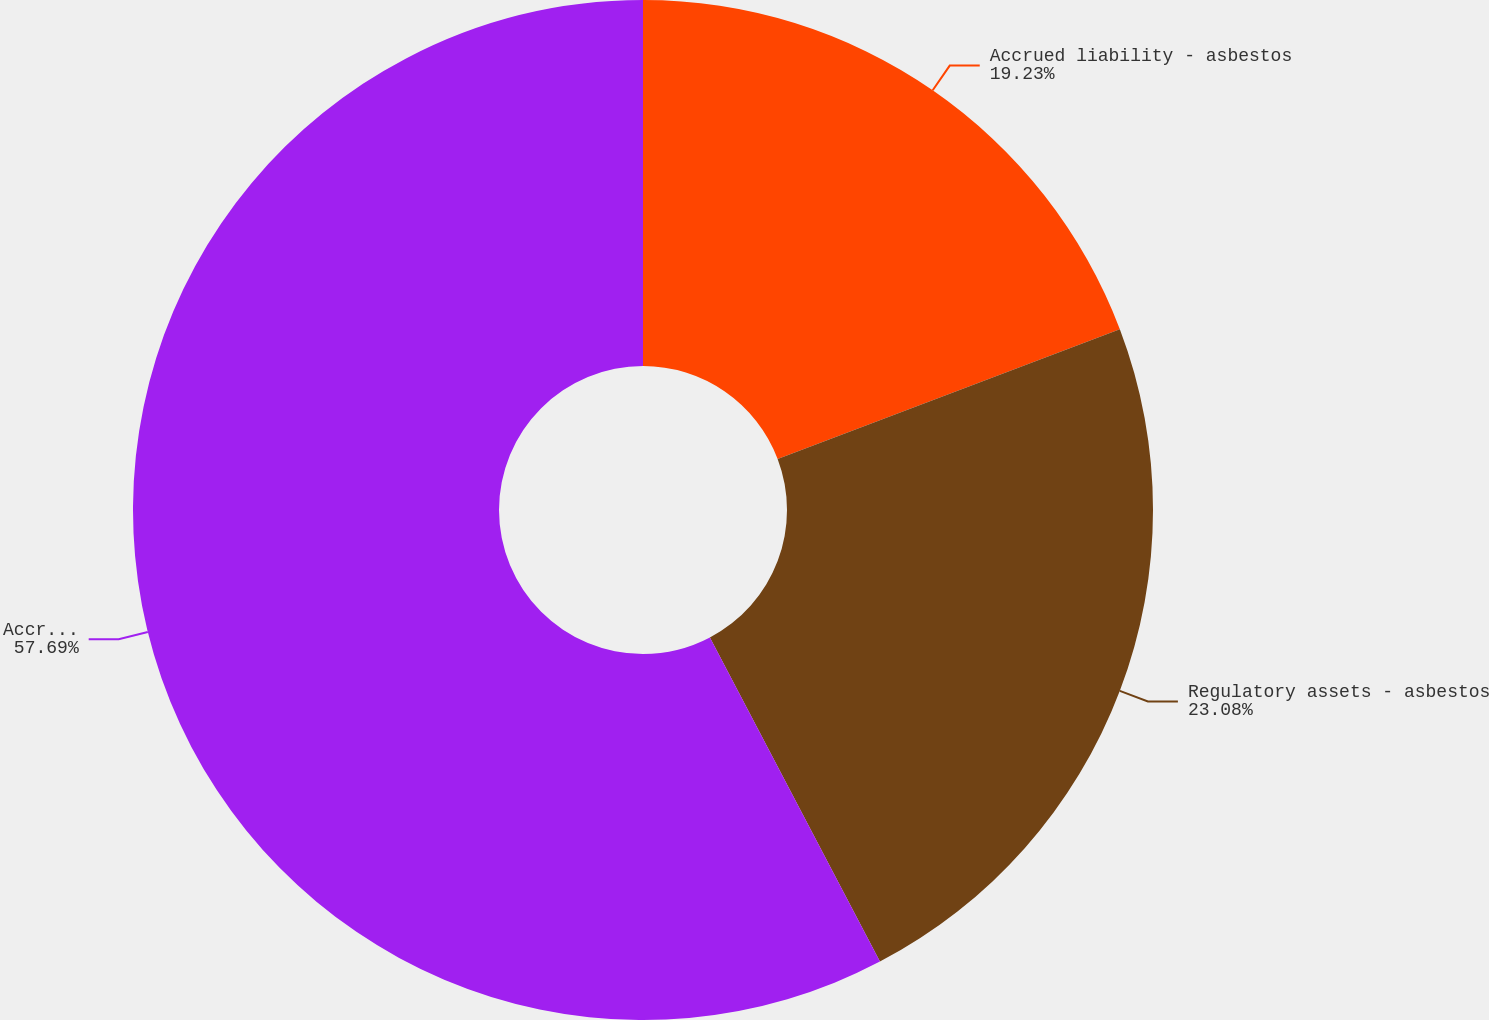Convert chart to OTSL. <chart><loc_0><loc_0><loc_500><loc_500><pie_chart><fcel>Accrued liability - asbestos<fcel>Regulatory assets - asbestos<fcel>Accrued liability - workers'<nl><fcel>19.23%<fcel>23.08%<fcel>57.69%<nl></chart> 